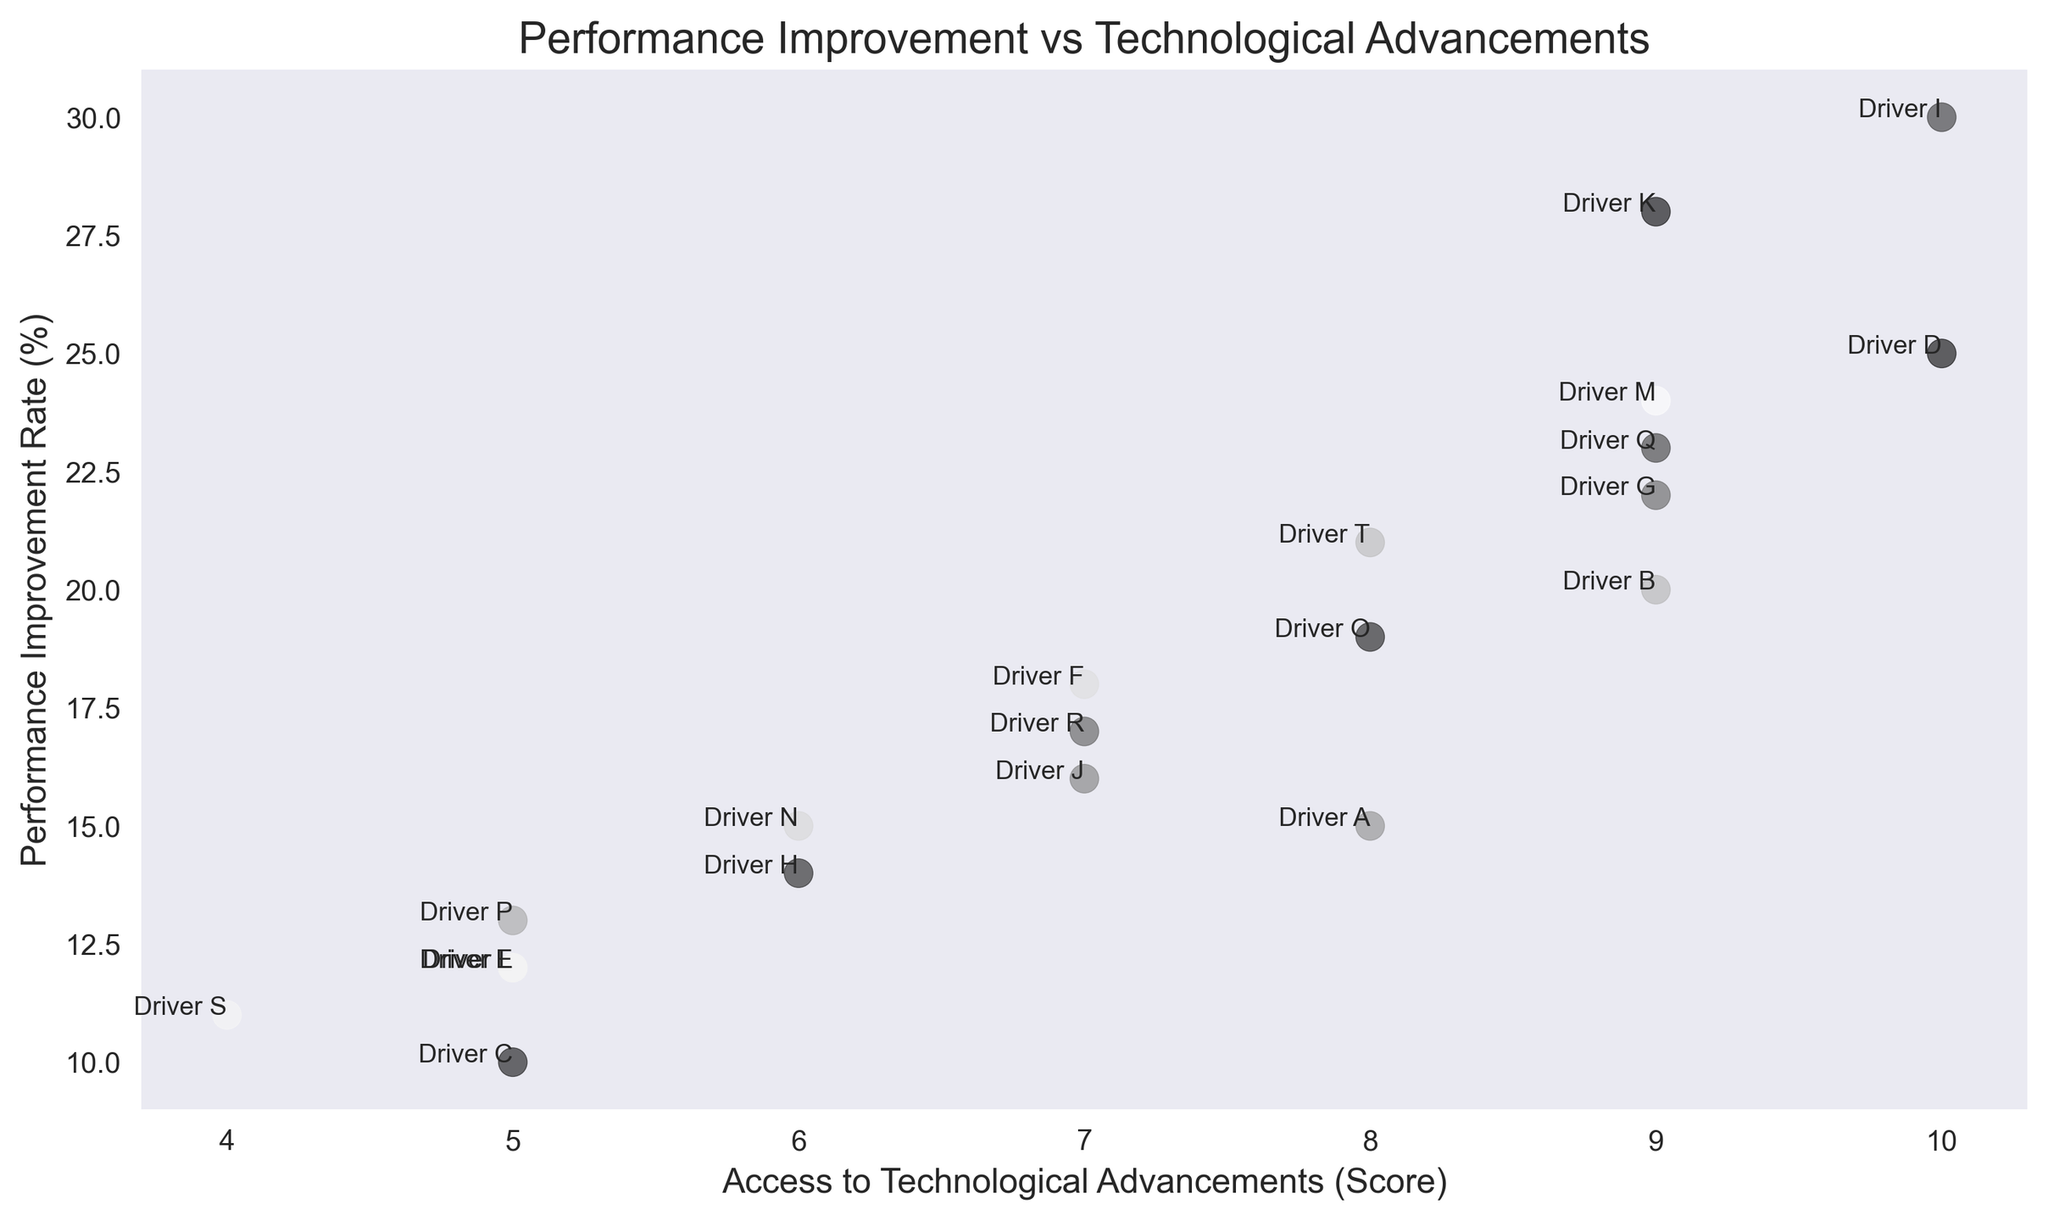What's the maximum performance improvement rate shown in the figure? The figure depicts various drivers with different performance improvement rates. By looking at the y-axis and identifying the highest data point, we find that Driver I has a performance improvement rate of 30%.
Answer: 30% Who has the lowest access to technological advancements score? To identify the driver with the lowest access to technological advancements score, look at the x-axis and find the smallest score, which is 4. Driver S corresponds to this score.
Answer: Driver S How many drivers have an access to technological advancements score of 9? By examining the x-axis for the score of 9 and counting the corresponding data points, there are 5 drivers: B, G, K, M, and Q.
Answer: 5 Compare the performance improvement rates of Driver I and Driver D. Which is higher and by how much? Driver I has a performance improvement rate of 30%, and Driver D has a rate of 25%. Subtracting the two, 30% - 25%, we find that Driver I's rate is 5% higher than Driver D's.
Answer: Driver I by 5% What is the average performance improvement rate for drivers with an access to technological advancements score of 5? The drivers with a score of 5 are C, E, L, and P. Their performance improvement rates are 10%, 12%, 12%, and 13% respectively. Average = (10 + 12 + 12 + 13) / 4 = 11.75%.
Answer: 11.75% Is there a positive correlation between performance improvement rate and access to technological advancements? Observing the general trend of the scatter plot, higher access to technological advancements tends to correspond with higher performance improvement rates, indicating a positive correlation.
Answer: Yes How many drivers have a performance improvement rate below 15%? By scanning the y-axis and counting the data points below 15%, the drivers are C, E, H, L, N, P, and S.
Answer: 7 What's the combined performance improvement rate for drivers with an access to technological advancements score of 8? The drivers with a score of 8 are A, O, and T with performance rates of 15%, 19%, and 21%. Sum = 15 + 19 + 21 = 55%.
Answer: 55% Which driver has the highest performance improvement rate while having high access to technological advancements (score of 10)? From the scatter plot, Driver I has the highest performance improvement rate (30%) among those with an access score of 10.
Answer: Driver I Compare the drivers with the same access score but different performance rates. For scores of 7, which driver performs better? Drivers F, J, and R have an access score of 7. Their performance improvement rates are 18%, 16%, and 17% respectively. F performs better with an 18% rate.
Answer: Driver F 